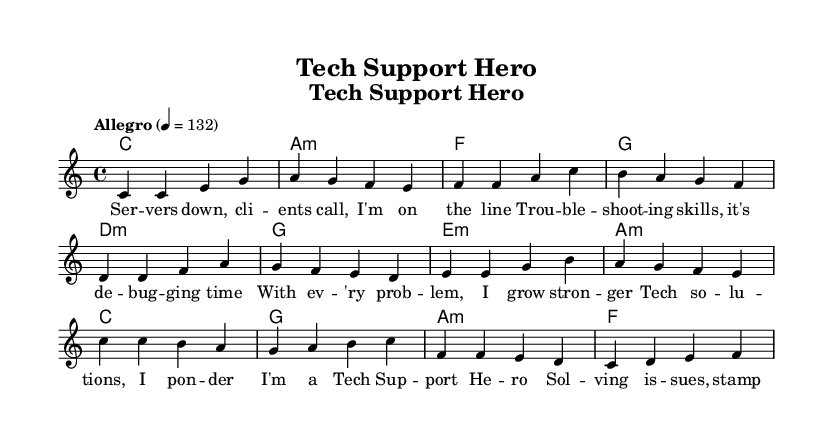What is the key signature of this music? The key signature is C major, which is indicated by no sharps or flats. This is determined by looking at the key signature symbol at the beginning of the sheet music.
Answer: C major What is the time signature of this music? The time signature is 4/4, which means there are four beats in each measure. This can be found at the beginning of the staff, directly indicating the structure of the rhythm throughout the piece.
Answer: 4/4 What is the tempo marking of this music? The tempo marking is "Allegro" at a speed of 132 beats per minute. This is specified in the tempo instruction at the beginning of the score, indicating a fast and lively tempo.
Answer: Allegro 132 How many measures are in the verse section? There are four measures in the verse section, as counted by examining the melody notes grouped into measures from the start of the verse lyrics to the end. Each set of four notes separated by vertical lines signifies a measure.
Answer: 4 Which chord follows the first measure of the chorus? The chord following the first measure of the chorus is G major. This is identified by looking at the chord symbols placed above the staff, corresponding to the melody notes played in that measure.
Answer: G Is the chorus section longer or shorter than the verse section? The chorus section is shorter than the verse section, as it contains only four measures compared to the verse's four measures before transitioning. This requires analyzing the number of measures in both sections.
Answer: Shorter What is the main theme conveyed in the lyrics? The main theme is problem-solving and overcoming challenges within a technical support context. This theme is derived from the lyrical content that emphasizes troubleshooting and gaining strength through problem resolution.
Answer: Problem-solving 